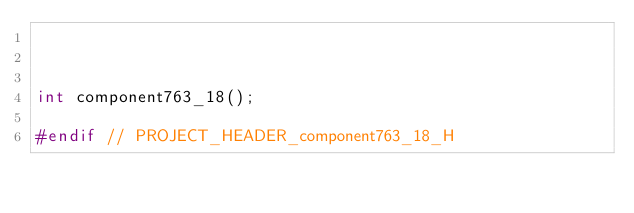<code> <loc_0><loc_0><loc_500><loc_500><_C_>


int component763_18();

#endif // PROJECT_HEADER_component763_18_H</code> 